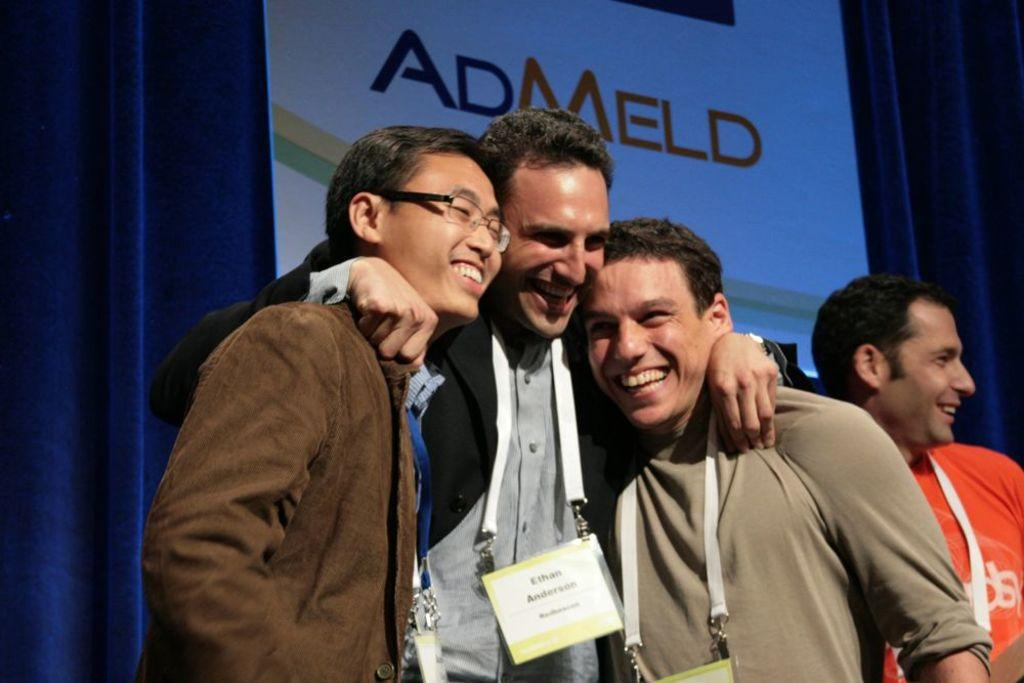How many people are in the image? There are four persons in the image. What are the persons wearing? The persons are wearing different color dresses. What are the persons doing in the image? The persons are standing and laughing. Where does the scene take place? The scene takes place on a stage. What can be seen in the background of the image? There is a hoarding in the background, and it is on a violet color curtain. What advice does the mom give to the person in the image? There is no mom present in the image, so it is not possible to answer that question. 